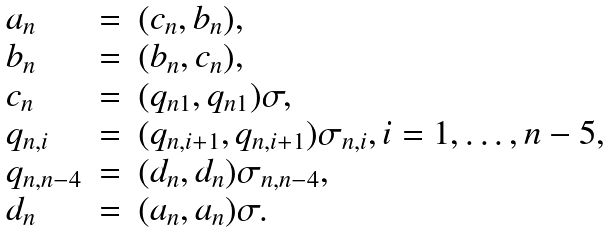Convert formula to latex. <formula><loc_0><loc_0><loc_500><loc_500>\begin{array} { l c l } a _ { n } & = & ( c _ { n } , b _ { n } ) , \\ b _ { n } & = & ( b _ { n } , c _ { n } ) , \\ c _ { n } & = & ( q _ { n 1 } , q _ { n 1 } ) \sigma , \\ q _ { n , i } & = & ( q _ { n , i + 1 } , q _ { n , i + 1 } ) \sigma _ { n , i } , i = 1 , \dots , n - 5 , \\ q _ { n , n - 4 } & = & ( d _ { n } , d _ { n } ) \sigma _ { n , n - 4 } , \\ d _ { n } & = & ( a _ { n } , a _ { n } ) \sigma . \\ \end{array}</formula> 